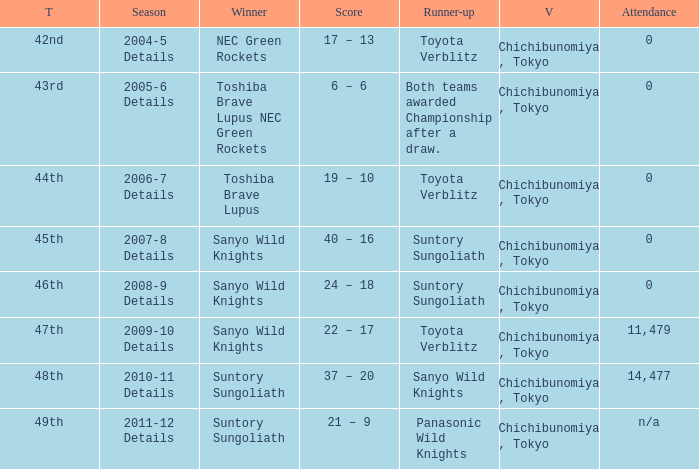What is the Title when the winner was suntory sungoliath, and a Season of 2011-12 details? 49th. 